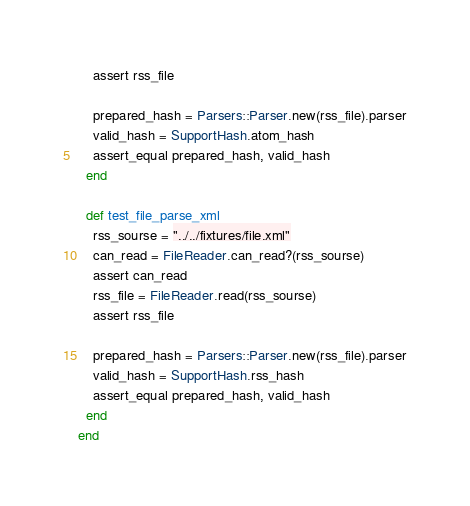Convert code to text. <code><loc_0><loc_0><loc_500><loc_500><_Ruby_>    assert rss_file

    prepared_hash = Parsers::Parser.new(rss_file).parser
    valid_hash = SupportHash.atom_hash
    assert_equal prepared_hash, valid_hash
  end

  def test_file_parse_xml
    rss_sourse = "../../fixtures/file.xml"
    can_read = FileReader.can_read?(rss_sourse)
    assert can_read
    rss_file = FileReader.read(rss_sourse)
    assert rss_file

    prepared_hash = Parsers::Parser.new(rss_file).parser
    valid_hash = SupportHash.rss_hash
    assert_equal prepared_hash, valid_hash
  end
end
</code> 